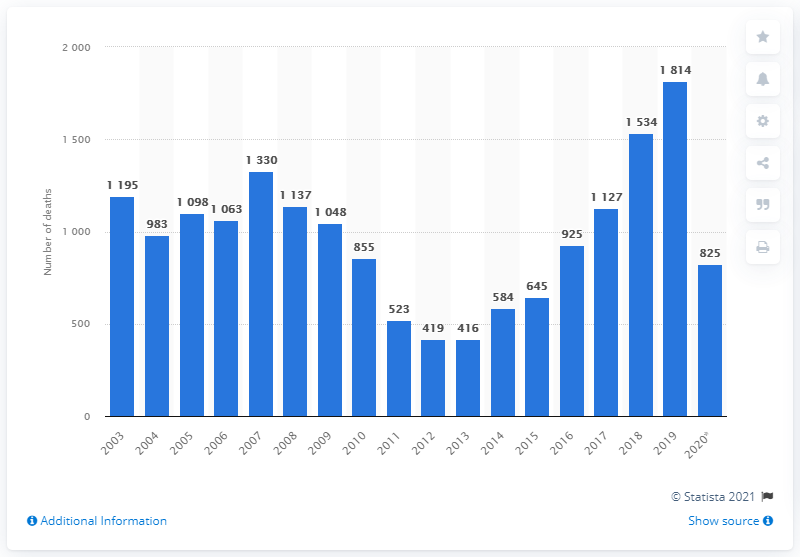Specify some key components in this picture. In the period between 2013 and 2019, a total of 1,814 individuals were killed by police in Rio de Janeiro. 